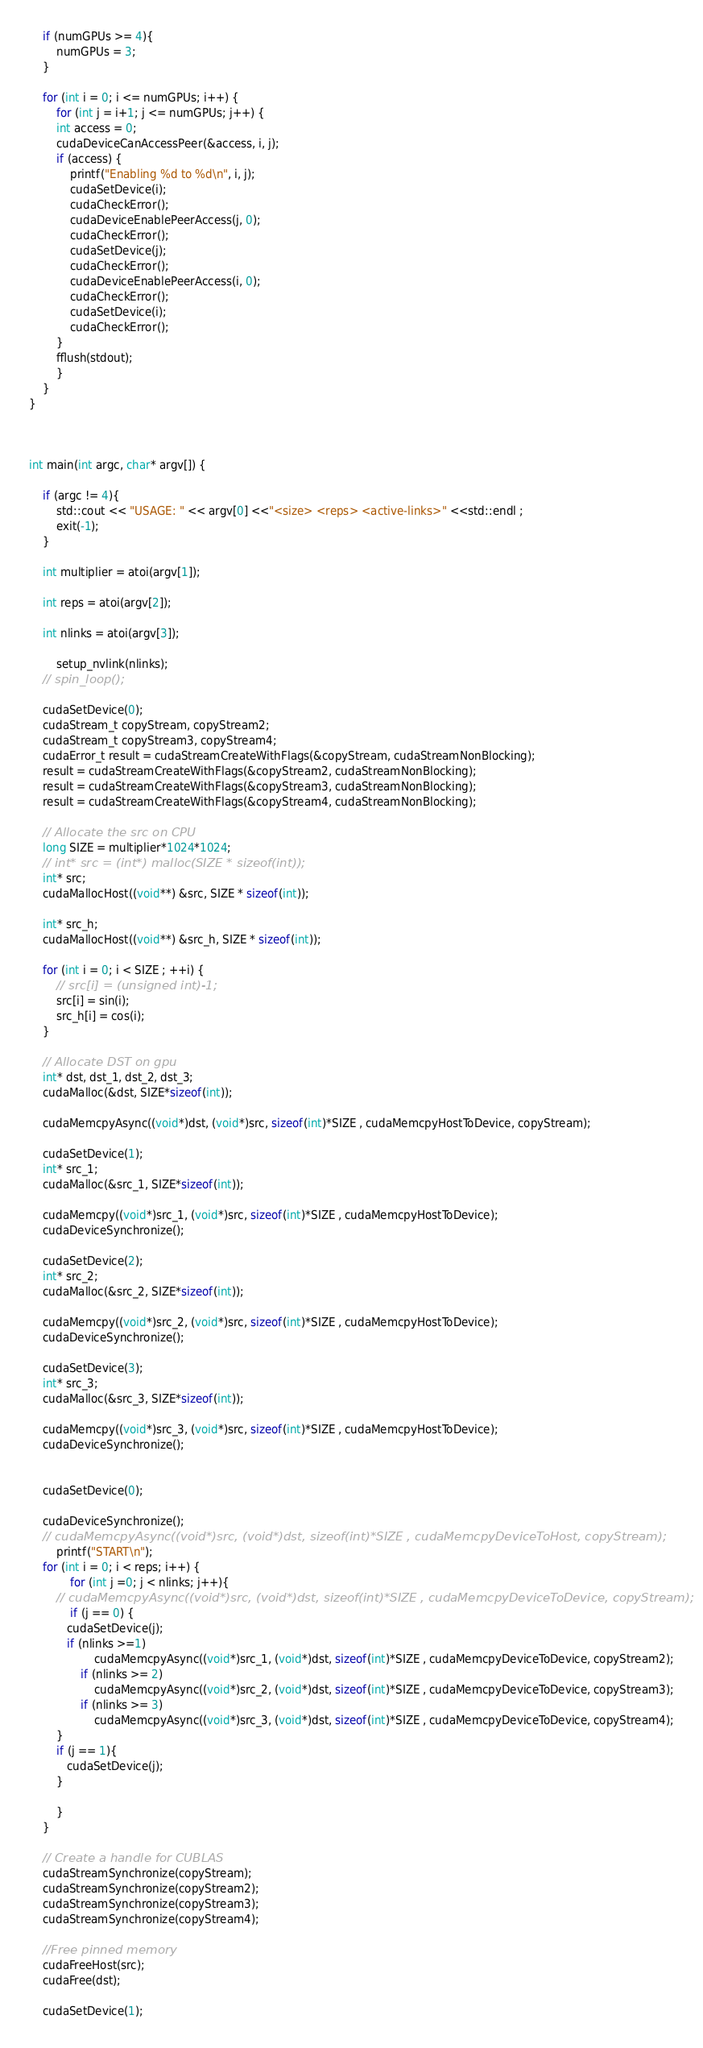Convert code to text. <code><loc_0><loc_0><loc_500><loc_500><_Cuda_>	if (numGPUs >= 4){
	    numGPUs = 3;
	}

	for (int i = 0; i <= numGPUs; i++) {
	    for (int j = i+1; j <= numGPUs; j++) {
		int access = 0;
		cudaDeviceCanAccessPeer(&access, i, j);
		if (access) {
			printf("Enabling %d to %d\n", i, j);
			cudaSetDevice(i);
			cudaCheckError();
			cudaDeviceEnablePeerAccess(j, 0);
			cudaCheckError();
			cudaSetDevice(j);
			cudaCheckError();
			cudaDeviceEnablePeerAccess(i, 0);
			cudaCheckError();
			cudaSetDevice(i);
			cudaCheckError();
		}
		fflush(stdout);
	    }
	}
}



int main(int argc, char* argv[]) {
        
	if (argc != 4){
		std::cout << "USAGE: " << argv[0] <<"<size> <reps> <active-links>" <<std::endl ;
		exit(-1);
	}

	int multiplier = atoi(argv[1]);

	int reps = atoi(argv[2]);
	
	int nlinks = atoi(argv[3]);
        
        setup_nvlink(nlinks);
	// spin_loop();

	cudaSetDevice(0);
	cudaStream_t copyStream, copyStream2;
	cudaStream_t copyStream3, copyStream4;
	cudaError_t result = cudaStreamCreateWithFlags(&copyStream, cudaStreamNonBlocking);
	result = cudaStreamCreateWithFlags(&copyStream2, cudaStreamNonBlocking);
	result = cudaStreamCreateWithFlags(&copyStream3, cudaStreamNonBlocking);
	result = cudaStreamCreateWithFlags(&copyStream4, cudaStreamNonBlocking);

	// Allocate the src on CPU
	long SIZE = multiplier*1024*1024;
	// int* src = (int*) malloc(SIZE * sizeof(int));
	int* src; 
	cudaMallocHost((void**) &src, SIZE * sizeof(int));

	int* src_h; 
	cudaMallocHost((void**) &src_h, SIZE * sizeof(int));

	for (int i = 0; i < SIZE ; ++i) {
		// src[i] = (unsigned int)-1;
		src[i] = sin(i);
		src_h[i] = cos(i);
	}

	// Allocate DST on gpu	
	int* dst, dst_1, dst_2, dst_3;
	cudaMalloc(&dst, SIZE*sizeof(int));

	cudaMemcpyAsync((void*)dst, (void*)src, sizeof(int)*SIZE , cudaMemcpyHostToDevice, copyStream);
	
	cudaSetDevice(1);
	int* src_1;
	cudaMalloc(&src_1, SIZE*sizeof(int));

	cudaMemcpy((void*)src_1, (void*)src, sizeof(int)*SIZE , cudaMemcpyHostToDevice);
	cudaDeviceSynchronize();

	cudaSetDevice(2);
	int* src_2;
	cudaMalloc(&src_2, SIZE*sizeof(int));

	cudaMemcpy((void*)src_2, (void*)src, sizeof(int)*SIZE , cudaMemcpyHostToDevice);
	cudaDeviceSynchronize();

	cudaSetDevice(3);
	int* src_3;
	cudaMalloc(&src_3, SIZE*sizeof(int));

	cudaMemcpy((void*)src_3, (void*)src, sizeof(int)*SIZE , cudaMemcpyHostToDevice);
	cudaDeviceSynchronize();


	cudaSetDevice(0);

	cudaDeviceSynchronize();
	// cudaMemcpyAsync((void*)src, (void*)dst, sizeof(int)*SIZE , cudaMemcpyDeviceToHost, copyStream);
        printf("START\n");
	for (int i = 0; i < reps; i++) {
            for (int j =0; j < nlinks; j++){ 
	    // cudaMemcpyAsync((void*)src, (void*)dst, sizeof(int)*SIZE , cudaMemcpyDeviceToDevice, copyStream);
	        if (j == 0) {
		   cudaSetDevice(j);
		   if (nlinks >=1)  
	    	       cudaMemcpyAsync((void*)src_1, (void*)dst, sizeof(int)*SIZE , cudaMemcpyDeviceToDevice, copyStream2);
	           if (nlinks >= 2)
	    	       cudaMemcpyAsync((void*)src_2, (void*)dst, sizeof(int)*SIZE , cudaMemcpyDeviceToDevice, copyStream3);
	           if (nlinks >= 3)
	    	       cudaMemcpyAsync((void*)src_3, (void*)dst, sizeof(int)*SIZE , cudaMemcpyDeviceToDevice, copyStream4);
		}
		if (j == 1){
		   cudaSetDevice(j);
		}
		
	    }        
	}

	// Create a handle for CUBLAS	        
	cudaStreamSynchronize(copyStream);
	cudaStreamSynchronize(copyStream2);
	cudaStreamSynchronize(copyStream3);
	cudaStreamSynchronize(copyStream4);

	//Free pinned memory
	cudaFreeHost(src);
	cudaFree(dst);
	
	cudaSetDevice(1);</code> 